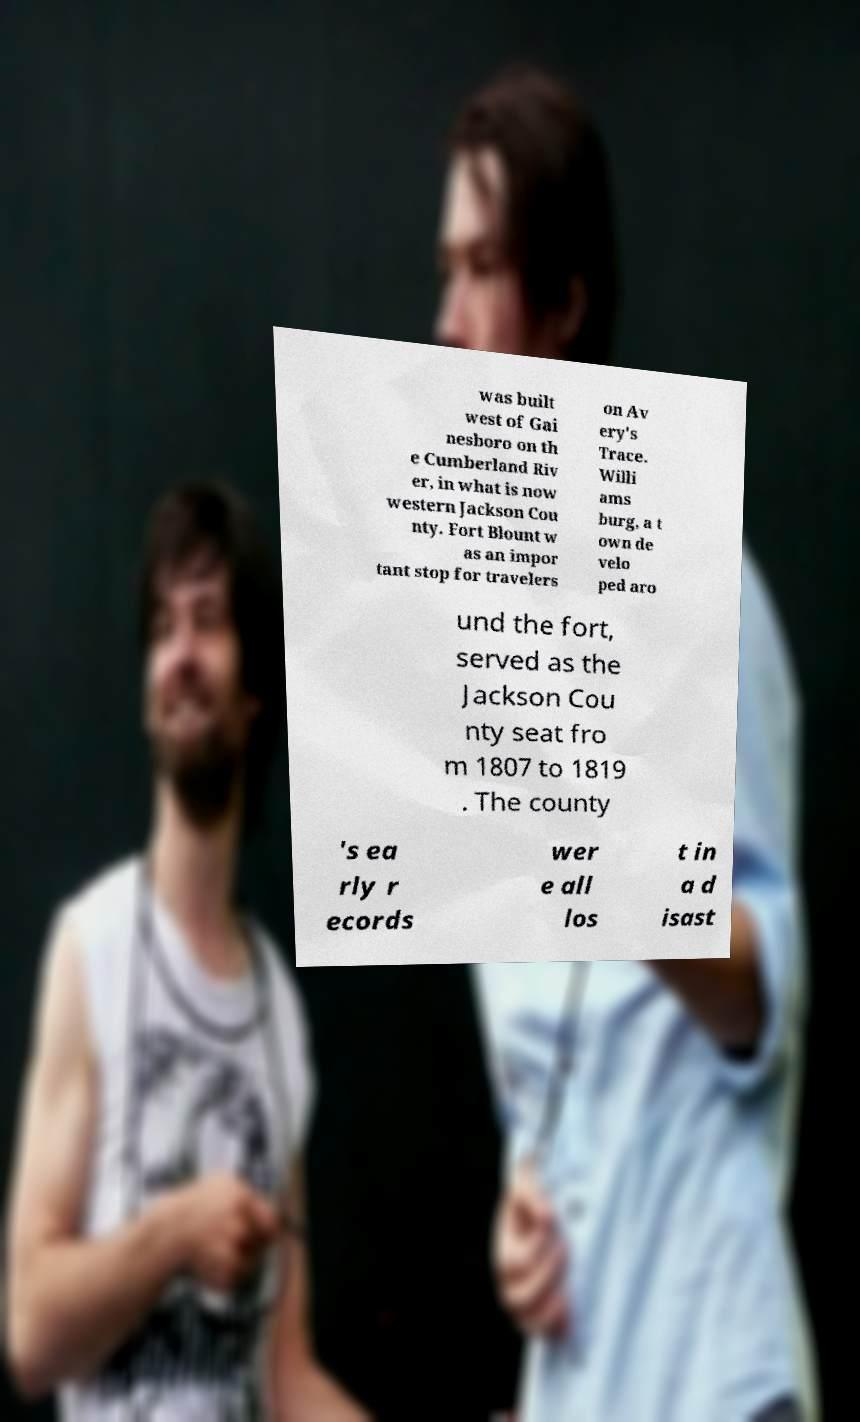Can you accurately transcribe the text from the provided image for me? was built west of Gai nesboro on th e Cumberland Riv er, in what is now western Jackson Cou nty. Fort Blount w as an impor tant stop for travelers on Av ery's Trace. Willi ams burg, a t own de velo ped aro und the fort, served as the Jackson Cou nty seat fro m 1807 to 1819 . The county 's ea rly r ecords wer e all los t in a d isast 